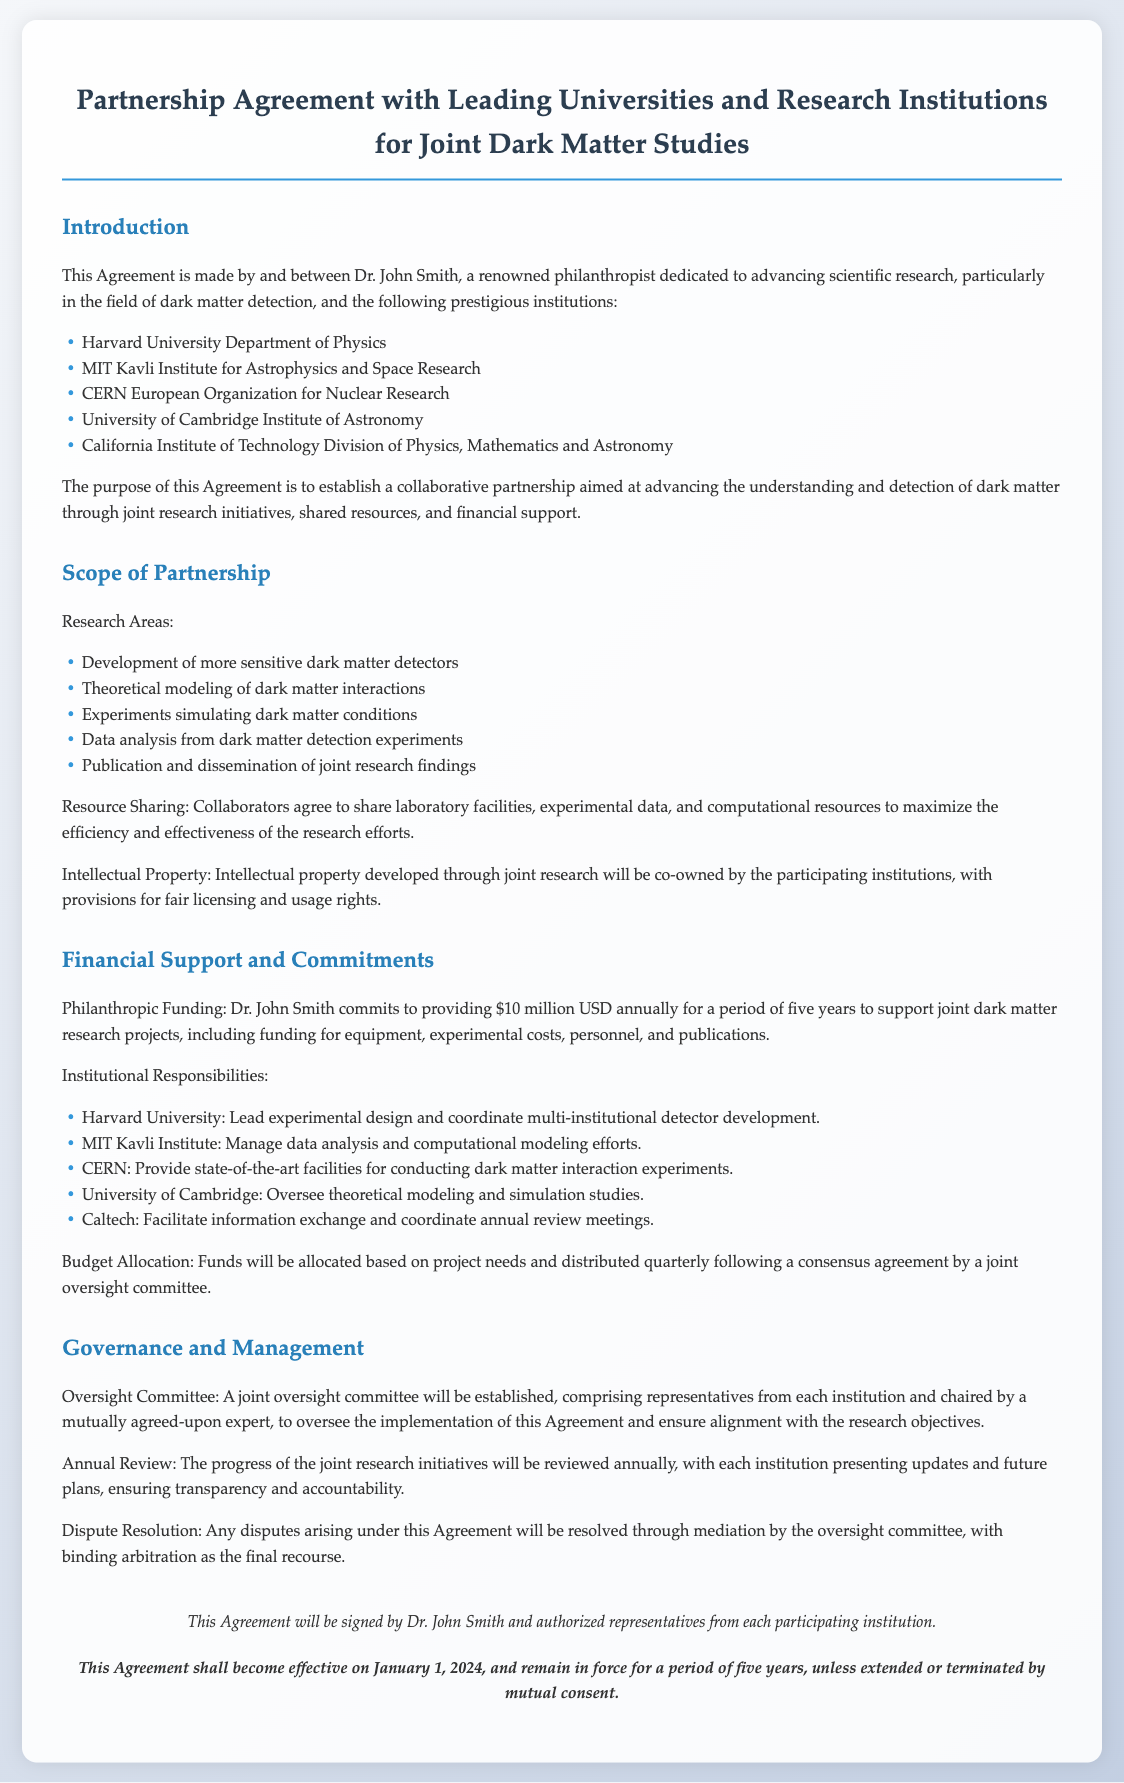What is the total amount of philanthropic funding committed? The document states Dr. John Smith commits to providing $10 million USD annually for five years, so the total funding is $10 million multiplied by 5 years.
Answer: $50 million Who leads the experimental design at Harvard University? The document specifies that Harvard University will lead experimental design and coordinate multi-institutional detector development.
Answer: Experimental design What is the effective date of the agreement? The document clearly states that the Agreement will become effective on January 1, 2024.
Answer: January 1, 2024 How many institutions are involved in the partnership? The agreement lists five prestigious institutions participating in the collaboration.
Answer: Five institutions What is the main purpose of the Agreement? The purpose as stated in the document is to establish a collaborative partnership aimed at advancing the understanding and detection of dark matter.
Answer: Collaborative partnership What type of committee will oversee the Agreement? According to the document, a joint oversight committee will be established to oversee the implementation of the Agreement.
Answer: Joint oversight committee What is the duration of the Agreement? The document specifies that the Agreement will remain in force for a period of five years unless extended or terminated by mutual consent.
Answer: Five years Which institution is responsible for managing data analysis? The MIT Kavli Institute is mentioned as responsible for managing data analysis and computational modeling efforts.
Answer: MIT Kavli Institute What is the budget allocation based on? The document states that funds will be allocated based on project needs and distributed quarterly following a consensus agreement.
Answer: Project needs 